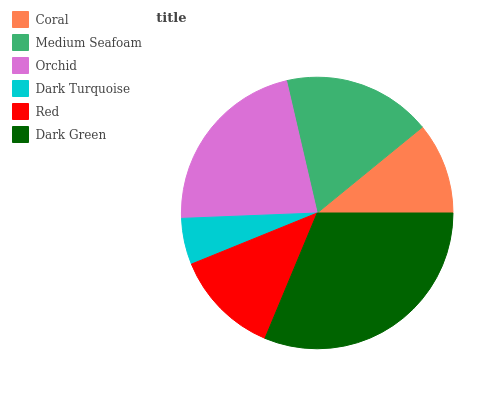Is Dark Turquoise the minimum?
Answer yes or no. Yes. Is Dark Green the maximum?
Answer yes or no. Yes. Is Medium Seafoam the minimum?
Answer yes or no. No. Is Medium Seafoam the maximum?
Answer yes or no. No. Is Medium Seafoam greater than Coral?
Answer yes or no. Yes. Is Coral less than Medium Seafoam?
Answer yes or no. Yes. Is Coral greater than Medium Seafoam?
Answer yes or no. No. Is Medium Seafoam less than Coral?
Answer yes or no. No. Is Medium Seafoam the high median?
Answer yes or no. Yes. Is Red the low median?
Answer yes or no. Yes. Is Coral the high median?
Answer yes or no. No. Is Coral the low median?
Answer yes or no. No. 